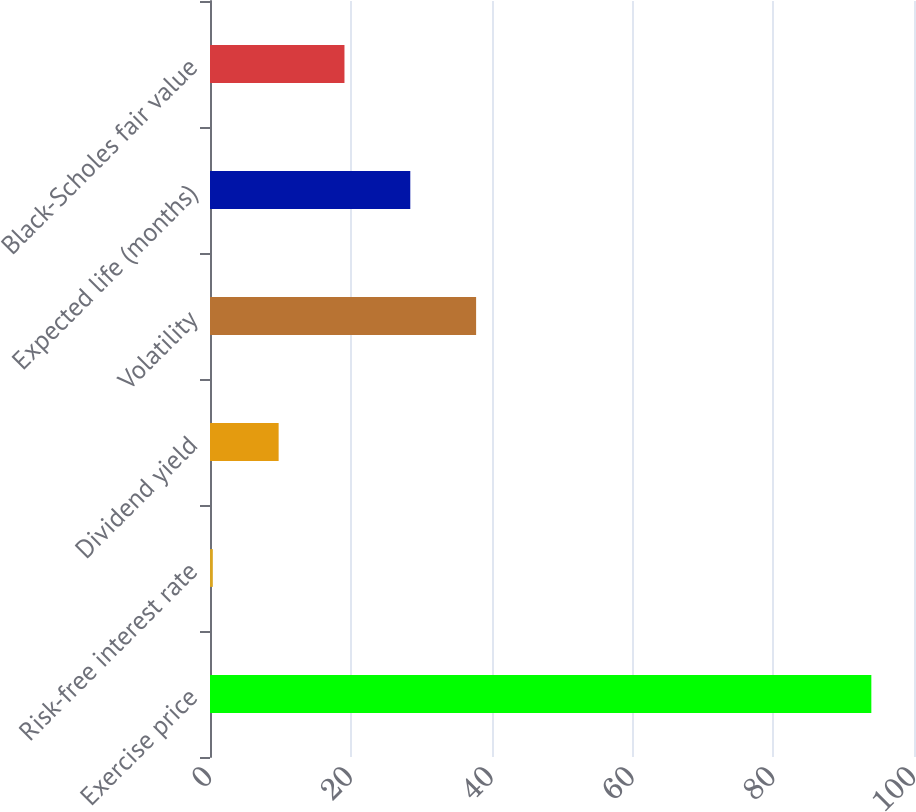Convert chart to OTSL. <chart><loc_0><loc_0><loc_500><loc_500><bar_chart><fcel>Exercise price<fcel>Risk-free interest rate<fcel>Dividend yield<fcel>Volatility<fcel>Expected life (months)<fcel>Black-Scholes fair value<nl><fcel>93.94<fcel>0.4<fcel>9.75<fcel>37.8<fcel>28.45<fcel>19.1<nl></chart> 